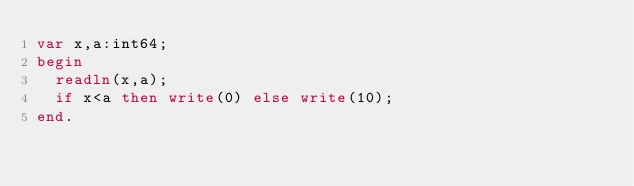Convert code to text. <code><loc_0><loc_0><loc_500><loc_500><_Pascal_>var x,a:int64;
begin
  readln(x,a);
  if x<a then write(0) else write(10);
end.</code> 